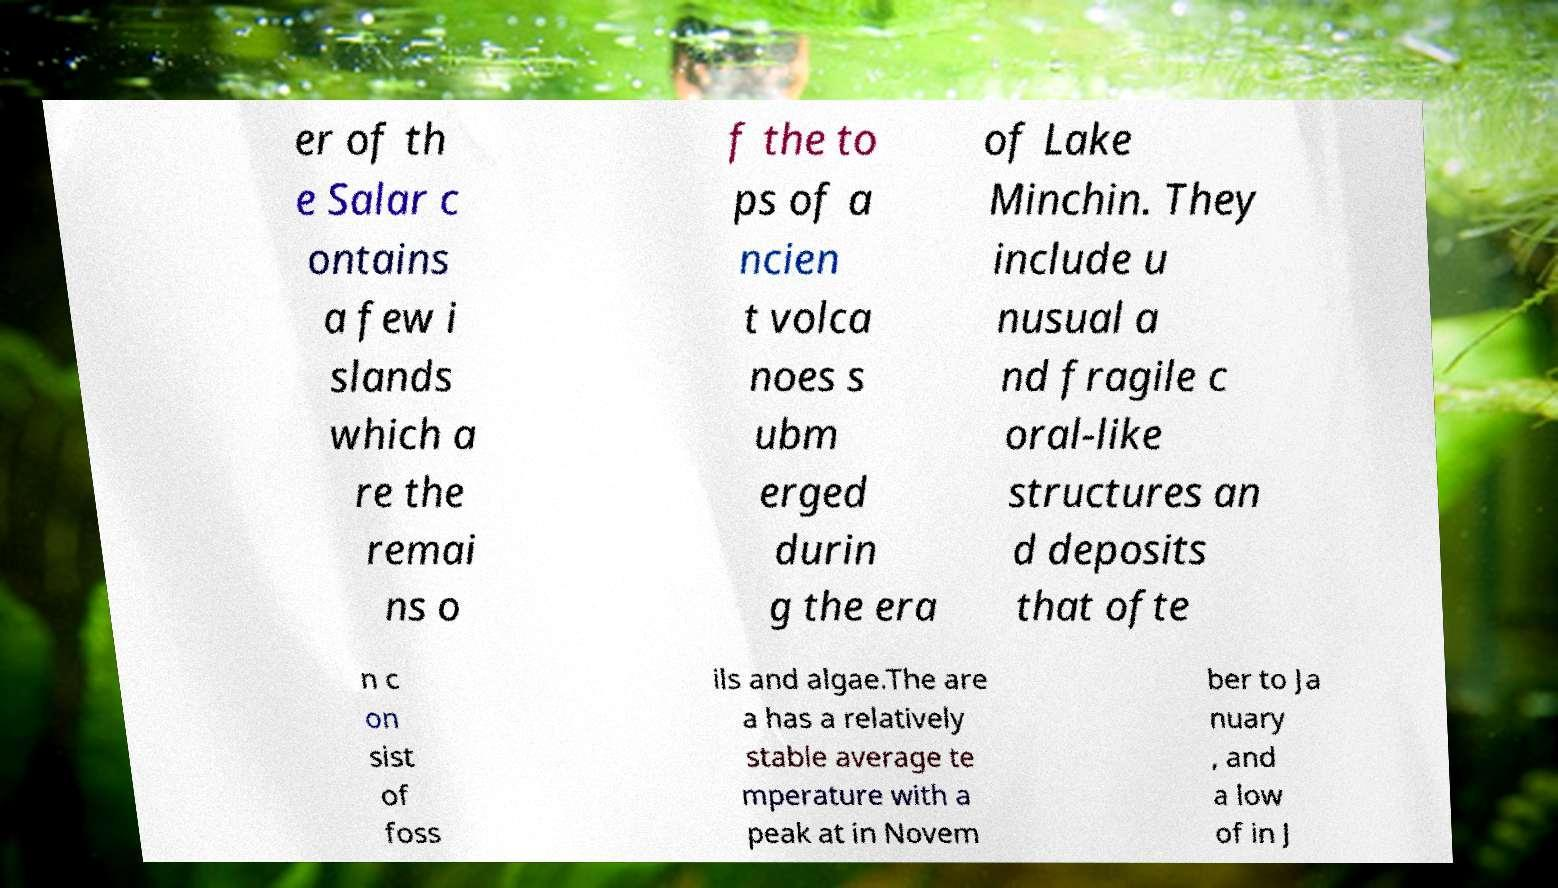Could you extract and type out the text from this image? er of th e Salar c ontains a few i slands which a re the remai ns o f the to ps of a ncien t volca noes s ubm erged durin g the era of Lake Minchin. They include u nusual a nd fragile c oral-like structures an d deposits that ofte n c on sist of foss ils and algae.The are a has a relatively stable average te mperature with a peak at in Novem ber to Ja nuary , and a low of in J 